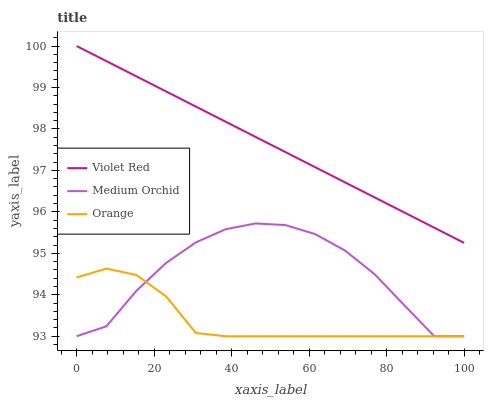Does Orange have the minimum area under the curve?
Answer yes or no. Yes. Does Violet Red have the maximum area under the curve?
Answer yes or no. Yes. Does Medium Orchid have the minimum area under the curve?
Answer yes or no. No. Does Medium Orchid have the maximum area under the curve?
Answer yes or no. No. Is Violet Red the smoothest?
Answer yes or no. Yes. Is Medium Orchid the roughest?
Answer yes or no. Yes. Is Medium Orchid the smoothest?
Answer yes or no. No. Is Violet Red the roughest?
Answer yes or no. No. Does Orange have the lowest value?
Answer yes or no. Yes. Does Violet Red have the lowest value?
Answer yes or no. No. Does Violet Red have the highest value?
Answer yes or no. Yes. Does Medium Orchid have the highest value?
Answer yes or no. No. Is Medium Orchid less than Violet Red?
Answer yes or no. Yes. Is Violet Red greater than Orange?
Answer yes or no. Yes. Does Medium Orchid intersect Orange?
Answer yes or no. Yes. Is Medium Orchid less than Orange?
Answer yes or no. No. Is Medium Orchid greater than Orange?
Answer yes or no. No. Does Medium Orchid intersect Violet Red?
Answer yes or no. No. 